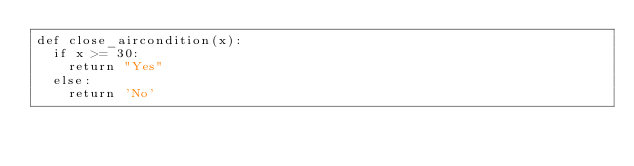Convert code to text. <code><loc_0><loc_0><loc_500><loc_500><_Python_>def close_aircondition(x):
  if x >= 30:
    return "Yes"
  else:
    return 'No'</code> 